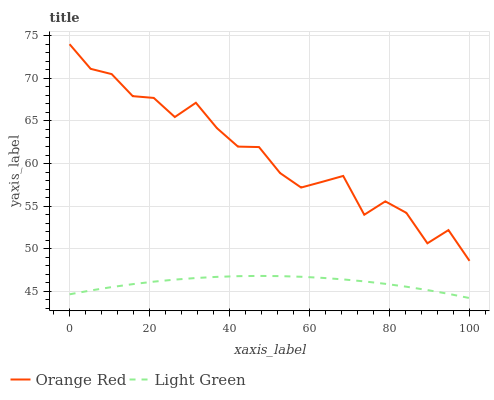Does Light Green have the maximum area under the curve?
Answer yes or no. No. Is Light Green the roughest?
Answer yes or no. No. Does Light Green have the highest value?
Answer yes or no. No. Is Light Green less than Orange Red?
Answer yes or no. Yes. Is Orange Red greater than Light Green?
Answer yes or no. Yes. Does Light Green intersect Orange Red?
Answer yes or no. No. 